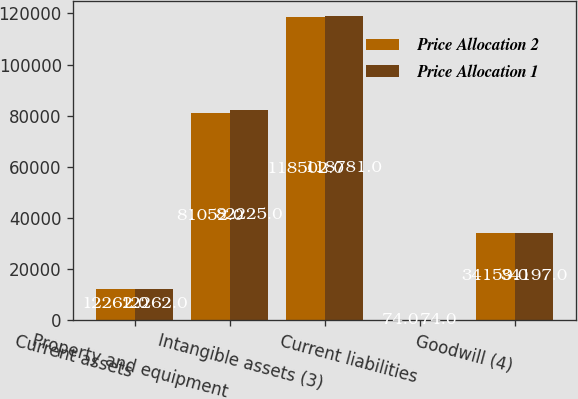Convert chart to OTSL. <chart><loc_0><loc_0><loc_500><loc_500><stacked_bar_chart><ecel><fcel>Current assets<fcel>Property and equipment<fcel>Intangible assets (3)<fcel>Current liabilities<fcel>Goodwill (4)<nl><fcel>Price Allocation 2<fcel>12262<fcel>81052<fcel>118502<fcel>74<fcel>34159<nl><fcel>Price Allocation 1<fcel>12262<fcel>82225<fcel>118781<fcel>74<fcel>34197<nl></chart> 